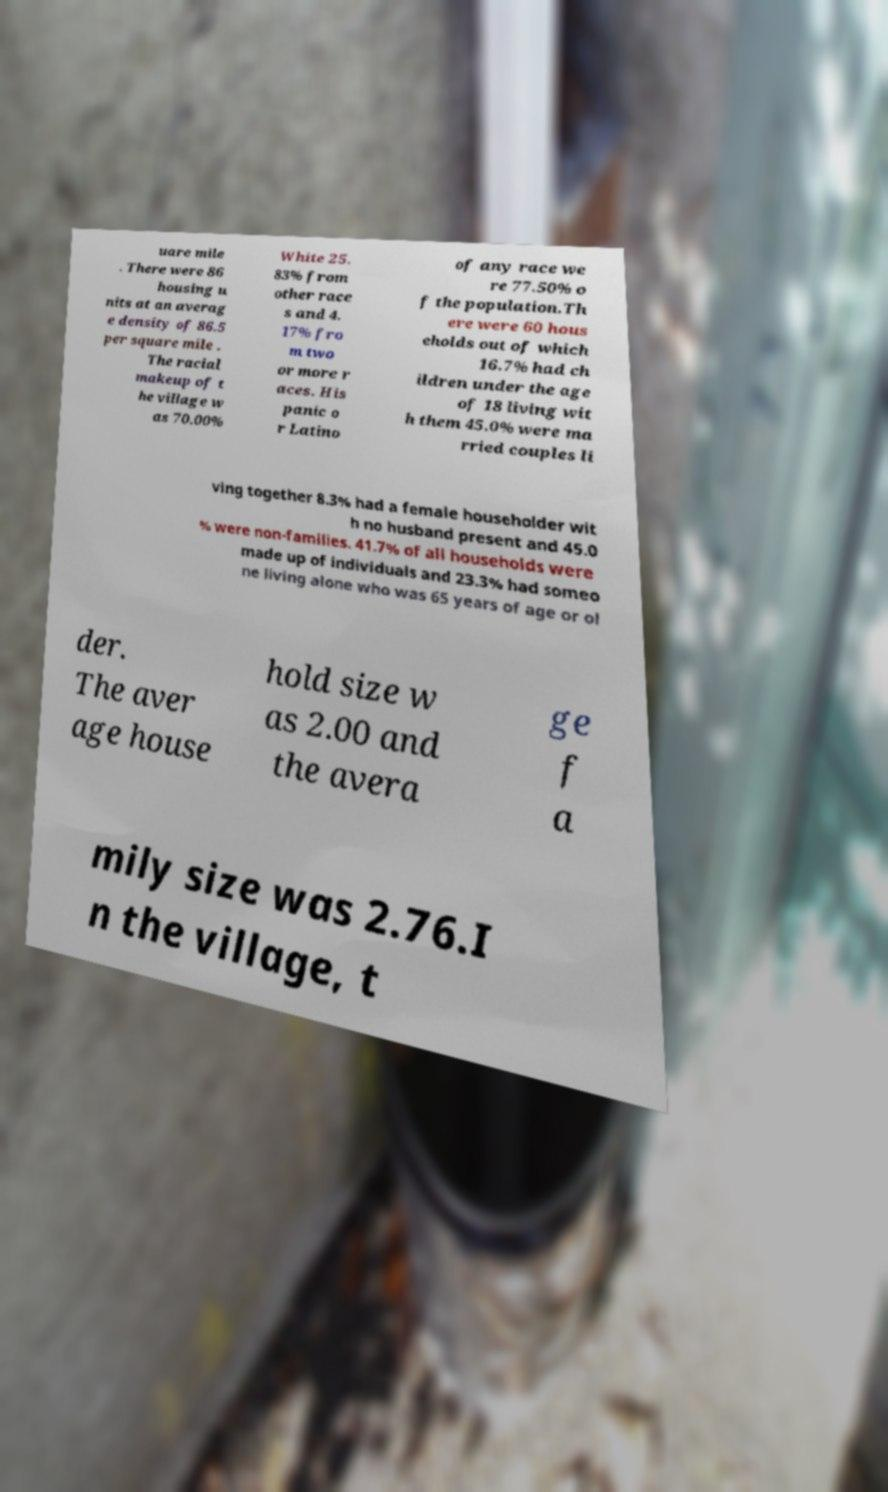Could you assist in decoding the text presented in this image and type it out clearly? uare mile . There were 86 housing u nits at an averag e density of 86.5 per square mile . The racial makeup of t he village w as 70.00% White 25. 83% from other race s and 4. 17% fro m two or more r aces. His panic o r Latino of any race we re 77.50% o f the population.Th ere were 60 hous eholds out of which 16.7% had ch ildren under the age of 18 living wit h them 45.0% were ma rried couples li ving together 8.3% had a female householder wit h no husband present and 45.0 % were non-families. 41.7% of all households were made up of individuals and 23.3% had someo ne living alone who was 65 years of age or ol der. The aver age house hold size w as 2.00 and the avera ge f a mily size was 2.76.I n the village, t 